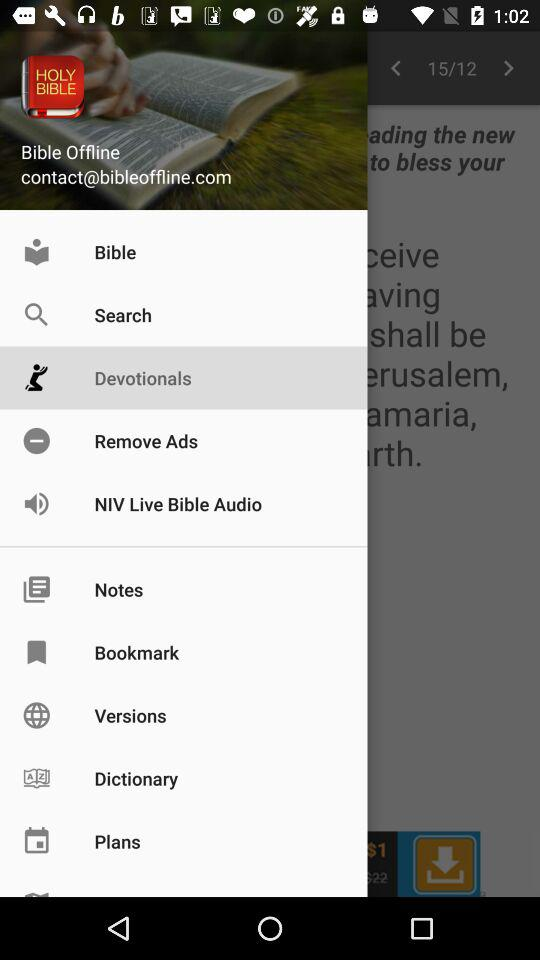What is the name of the application? The name of the application is "Bible Offline". 